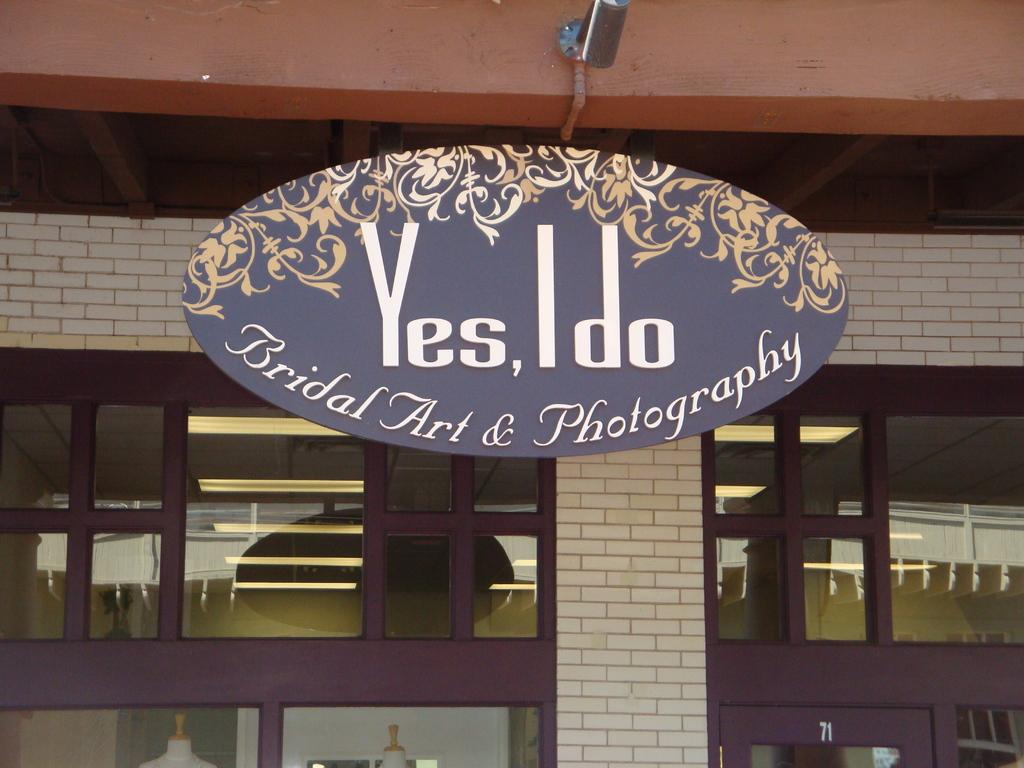Provide a one-sentence caption for the provided image. The storefront of a Bridal Art & Photography studio. 